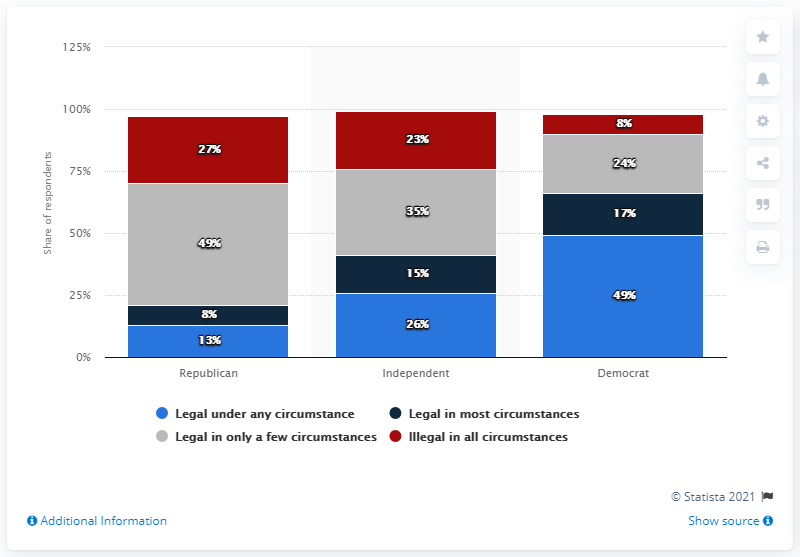What percentage of Republicans supported the legalization of abortion? According to the Statista 2021 chart, 13% of Republicans supported the legalization of abortion in only a few circumstances, while 8% supported legalization under any circumstance. It's important to note that the sum of these figures does not represent total support for legalization, as some respondents may support legality in most circumstances or none at all. 